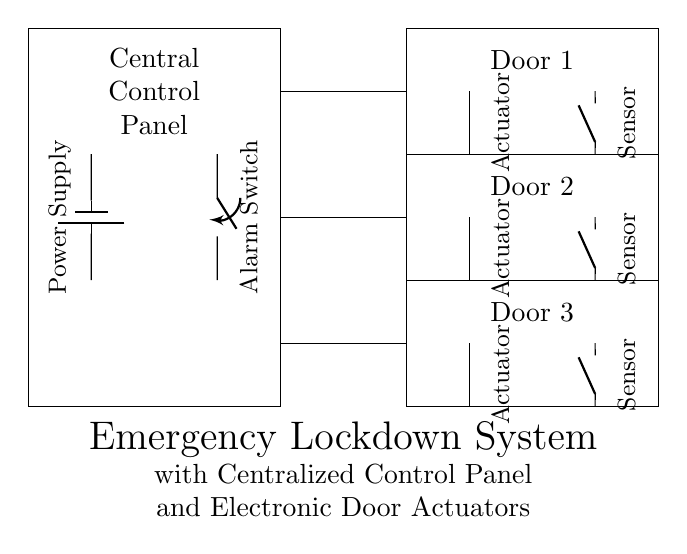What is the main component of this system? The main component is the Central Control Panel, which coordinates the operation of the entire emergency lockdown system.
Answer: Central Control Panel How many doors are connected to the control panel? The control panel is connected to three doors, as indicated by the three door sections in the diagram.
Answer: Three What type of switch is used for the alarm? The alarm is controlled by a single pole single throw switch, which can either enable or disable the alarm function.
Answer: SPST What is the function of the electronic door actuators? The electronic door actuators are responsible for locking or unlocking the doors, allowing for control over access during an emergency.
Answer: Locking/Unlocking What type of sensors are present at each door? Each door is equipped with a normally open sensor, which helps in detecting the door's status (open/closed) and feeds information back to the control panel.
Answer: Normally open sensors How is power supplied to the system? Power is supplied by a battery, as shown in the diagram, which provides the necessary voltage to operate the control panel and connected devices.
Answer: Battery 